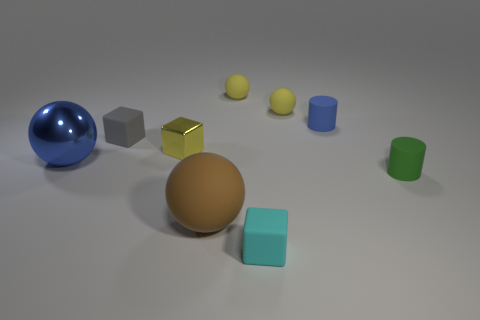Subtract all cyan blocks. How many blocks are left? 2 Subtract all matte cubes. How many cubes are left? 1 Subtract all balls. How many objects are left? 5 Subtract 3 blocks. How many blocks are left? 0 Subtract all purple cylinders. Subtract all red balls. How many cylinders are left? 2 Subtract all brown spheres. How many blue cylinders are left? 1 Subtract all yellow rubber spheres. Subtract all tiny yellow spheres. How many objects are left? 5 Add 7 metal balls. How many metal balls are left? 8 Add 8 large yellow matte objects. How many large yellow matte objects exist? 8 Subtract 0 cyan spheres. How many objects are left? 9 